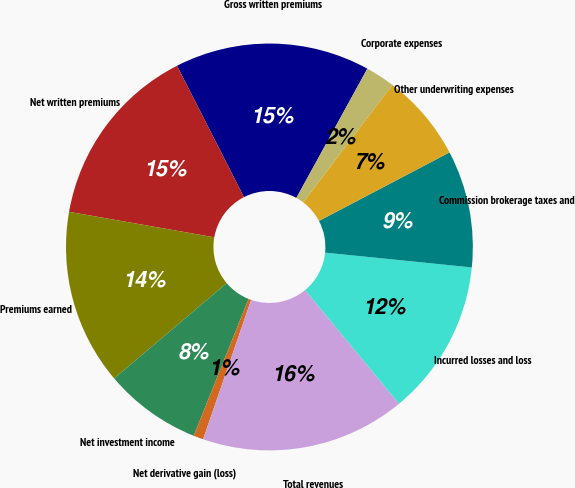<chart> <loc_0><loc_0><loc_500><loc_500><pie_chart><fcel>Gross written premiums<fcel>Net written premiums<fcel>Premiums earned<fcel>Net investment income<fcel>Net derivative gain (loss)<fcel>Total revenues<fcel>Incurred losses and loss<fcel>Commission brokerage taxes and<fcel>Other underwriting expenses<fcel>Corporate expenses<nl><fcel>15.5%<fcel>14.73%<fcel>13.95%<fcel>7.75%<fcel>0.78%<fcel>16.28%<fcel>12.4%<fcel>9.3%<fcel>6.98%<fcel>2.33%<nl></chart> 